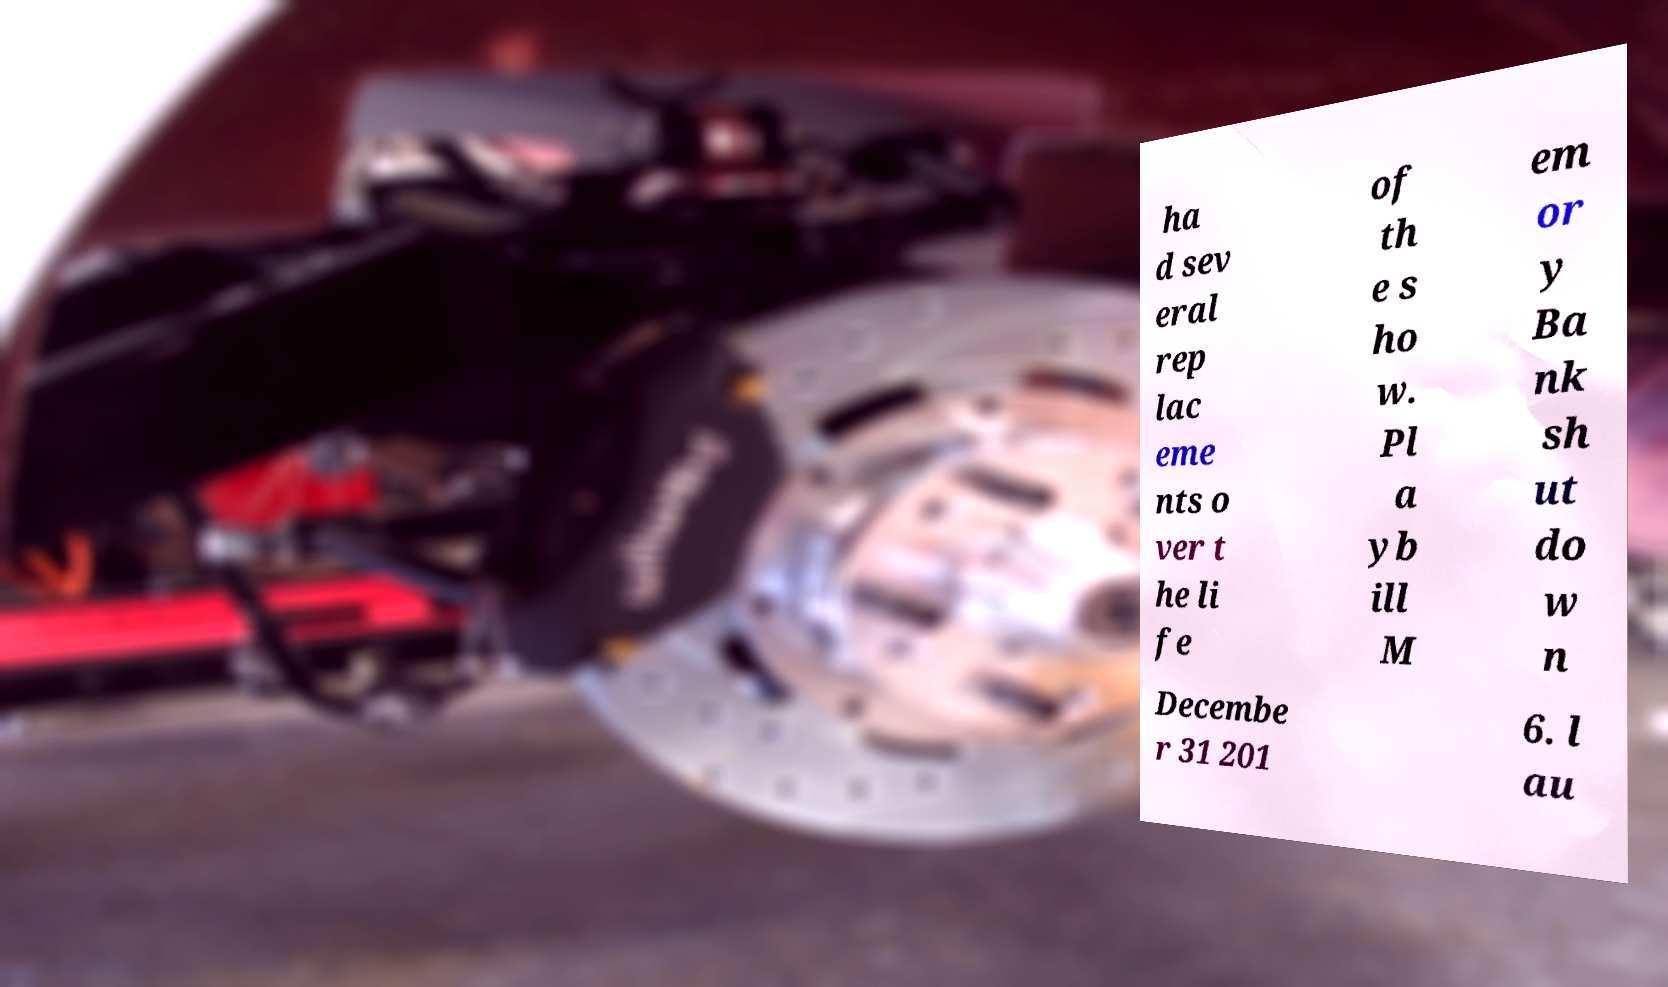What messages or text are displayed in this image? I need them in a readable, typed format. ha d sev eral rep lac eme nts o ver t he li fe of th e s ho w. Pl a yb ill M em or y Ba nk sh ut do w n Decembe r 31 201 6. l au 